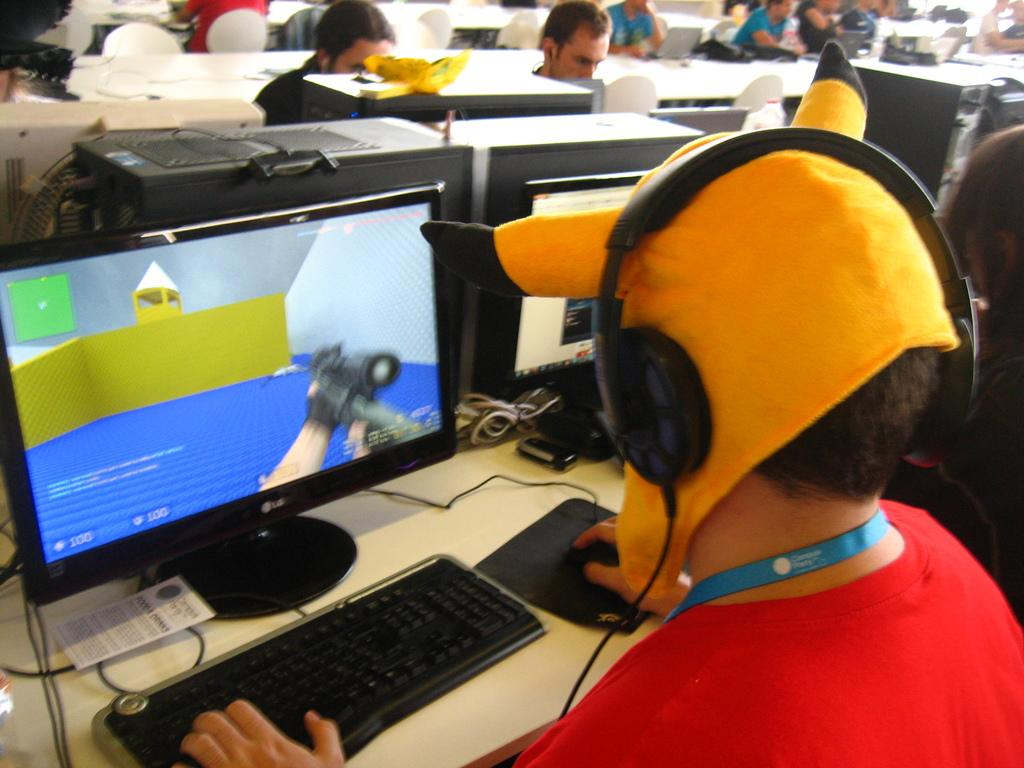What is the person in the image doing? There is a person sitting and working in the image. What is the person working in front of? The person is in front of a system. Can you describe the setting in the background of the image? There are other persons sitting in the background, along with chairs and tables. What color are the chairs and tables in the background? The chairs and tables are white in color. What type of pleasure boats can be seen in the image? There are no pleasure boats present in the image; it features a person working in front of a system. 